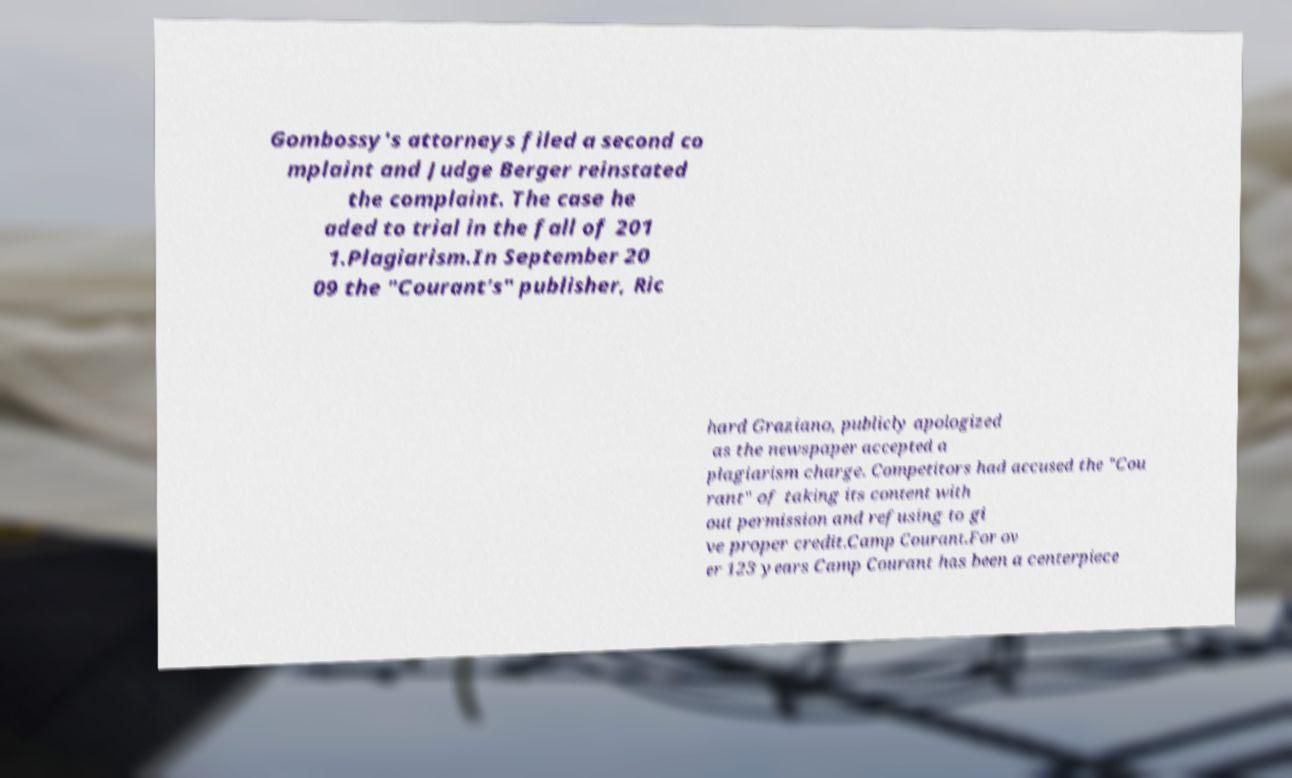What messages or text are displayed in this image? I need them in a readable, typed format. Gombossy's attorneys filed a second co mplaint and Judge Berger reinstated the complaint. The case he aded to trial in the fall of 201 1.Plagiarism.In September 20 09 the "Courant's" publisher, Ric hard Graziano, publicly apologized as the newspaper accepted a plagiarism charge. Competitors had accused the "Cou rant" of taking its content with out permission and refusing to gi ve proper credit.Camp Courant.For ov er 123 years Camp Courant has been a centerpiece 